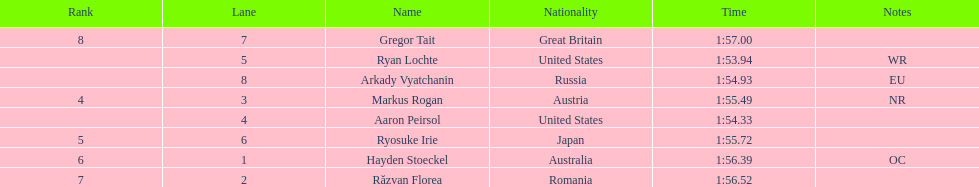Did austria or russia rank higher? Russia. 